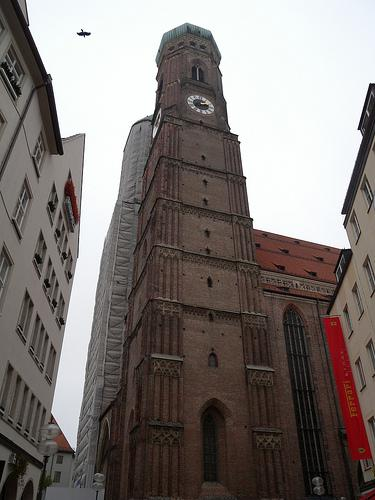Question: where is this picture being taken?
Choices:
A. On a rooftop.
B. In the street.
C. Inside a building.
D. In a park.
Answer with the letter. Answer: B Question: what is being photographed?
Choices:
A. A house.
B. A church.
C. A building.
D. A school.
Answer with the letter. Answer: C Question: how is the weather outside?
Choices:
A. Rainy and gray.
B. Snowy.
C. Cloudy.
D. Sunny and clear.
Answer with the letter. Answer: D Question: when was this picture taken?
Choices:
A. During the day.
B. Before the car crash.
C. When the photographer hit the button.
D. During the wedding.
Answer with the letter. Answer: A 